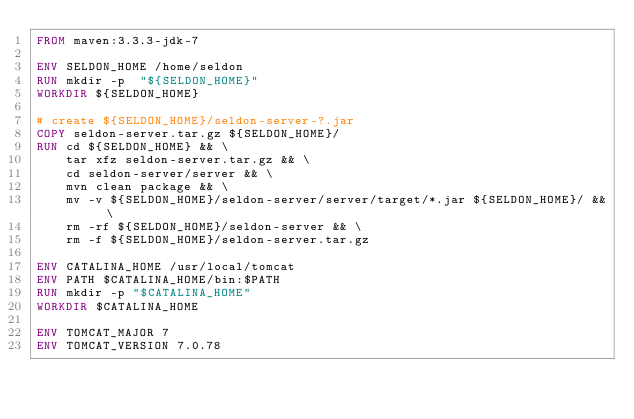<code> <loc_0><loc_0><loc_500><loc_500><_Dockerfile_>FROM maven:3.3.3-jdk-7

ENV SELDON_HOME /home/seldon
RUN mkdir -p  "${SELDON_HOME}"
WORKDIR ${SELDON_HOME}

# create ${SELDON_HOME}/seldon-server-?.jar
COPY seldon-server.tar.gz ${SELDON_HOME}/
RUN cd ${SELDON_HOME} && \
    tar xfz seldon-server.tar.gz && \
    cd seldon-server/server && \
    mvn clean package && \
    mv -v ${SELDON_HOME}/seldon-server/server/target/*.jar ${SELDON_HOME}/ && \
    rm -rf ${SELDON_HOME}/seldon-server && \
    rm -f ${SELDON_HOME}/seldon-server.tar.gz

ENV CATALINA_HOME /usr/local/tomcat
ENV PATH $CATALINA_HOME/bin:$PATH
RUN mkdir -p "$CATALINA_HOME"
WORKDIR $CATALINA_HOME

ENV TOMCAT_MAJOR 7
ENV TOMCAT_VERSION 7.0.78</code> 